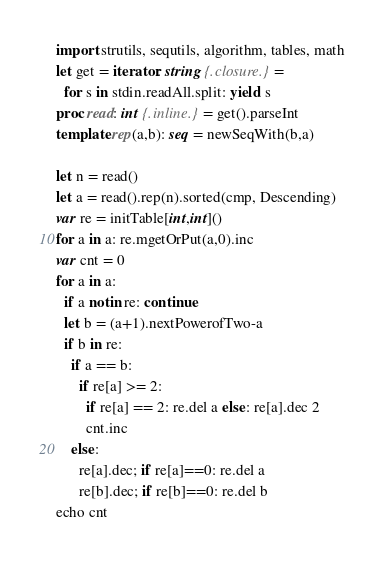<code> <loc_0><loc_0><loc_500><loc_500><_Nim_>import strutils, sequtils, algorithm, tables, math
let get = iterator: string {.closure.} =
  for s in stdin.readAll.split: yield s
proc read: int {.inline.} = get().parseInt
template rep(a,b): seq = newSeqWith(b,a)

let n = read()
let a = read().rep(n).sorted(cmp, Descending)
var re = initTable[int,int]()
for a in a: re.mgetOrPut(a,0).inc
var cnt = 0
for a in a:
  if a notin re: continue
  let b = (a+1).nextPowerofTwo-a
  if b in re:
    if a == b:
      if re[a] >= 2:
        if re[a] == 2: re.del a else: re[a].dec 2
        cnt.inc
    else:
      re[a].dec; if re[a]==0: re.del a
      re[b].dec; if re[b]==0: re.del b
echo cnt
</code> 